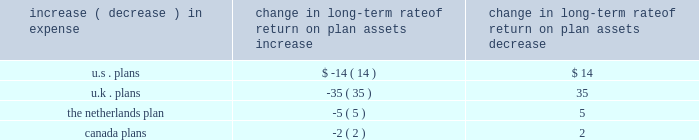Holding other assumptions constant , the table reflects what a one hundred basis point increase and decrease in our estimated long-term rate of return on plan assets would have on our estimated 2011 pension expense ( in millions ) : change in long-term rate of return on plan assets .
Estimated future contributions we estimate contributions of approximately $ 403 million in 2011 as compared with $ 288 million in goodwill and other intangible assets goodwill represents the excess of cost over the fair market value of the net assets acquired .
We classify our intangible assets acquired as either trademarks , customer relationships , technology , non-compete agreements , or other purchased intangibles .
Our goodwill and other intangible balances at december 31 , 2010 increased to $ 8.6 billion and $ 3.6 billion , respectively , compared to $ 6.1 billion and $ 791 million , respectively , at december 31 , 2009 , primarily as a result of the hewitt acquisition .
Although goodwill is not amortized , we test it for impairment at least annually in the fourth quarter .
In the fourth quarter , we also test acquired trademarks ( which also are not amortized ) for impairment .
We test more frequently if there are indicators of impairment or whenever business circumstances suggest that the carrying value of goodwill or trademarks may not be recoverable .
These indicators may include a sustained significant decline in our share price and market capitalization , a decline in our expected future cash flows , or a significant adverse change in legal factors or in the business climate , among others .
No events occurred during 2010 or 2009 that indicate the existence of an impairment with respect to our reported goodwill or trademarks .
We perform impairment reviews at the reporting unit level .
A reporting unit is an operating segment or one level below an operating segment ( referred to as a 2018 2018component 2019 2019 ) .
A component of an operating segment is a reporting unit if the component constitutes a business for which discrete financial information is available and segment management regularly reviews the operating results of that component .
An operating segment shall be deemed to be a reporting unit if all of its components are similar , if none of its components is a reporting unit , or if the segment comprises only a single component .
The goodwill impairment test is a two step analysis .
Step one requires the fair value of each reporting unit to be compared to its book value .
Management must apply judgment in determining the estimated fair value of the reporting units .
If the fair value of a reporting unit is determined to be greater than the carrying value of the reporting unit , goodwill and trademarks are deemed not to be impaired and no further testing is necessary .
If the fair value of a reporting unit is less than the carrying value , we perform step two .
Step two uses the calculated fair value of the reporting unit to perform a hypothetical purchase price allocation to the fair value of the assets and liabilities of the reporting unit .
The difference between the fair value of the reporting unit calculated in step one and the fair value of the underlying assets and liabilities of the reporting unit is the implied fair value of the reporting unit 2019s goodwill .
A charge is recorded in the financial statements if the carrying value of the reporting unit 2019s goodwill is greater than its implied fair value. .
What is the percentage change in goodwill from 2009 to 2010? 
Computations: ((8.6 - 6.1) / 6.1)
Answer: 0.40984. 